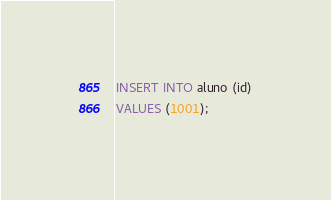Convert code to text. <code><loc_0><loc_0><loc_500><loc_500><_SQL_>INSERT INTO aluno (id)
VALUES (1001);
</code> 